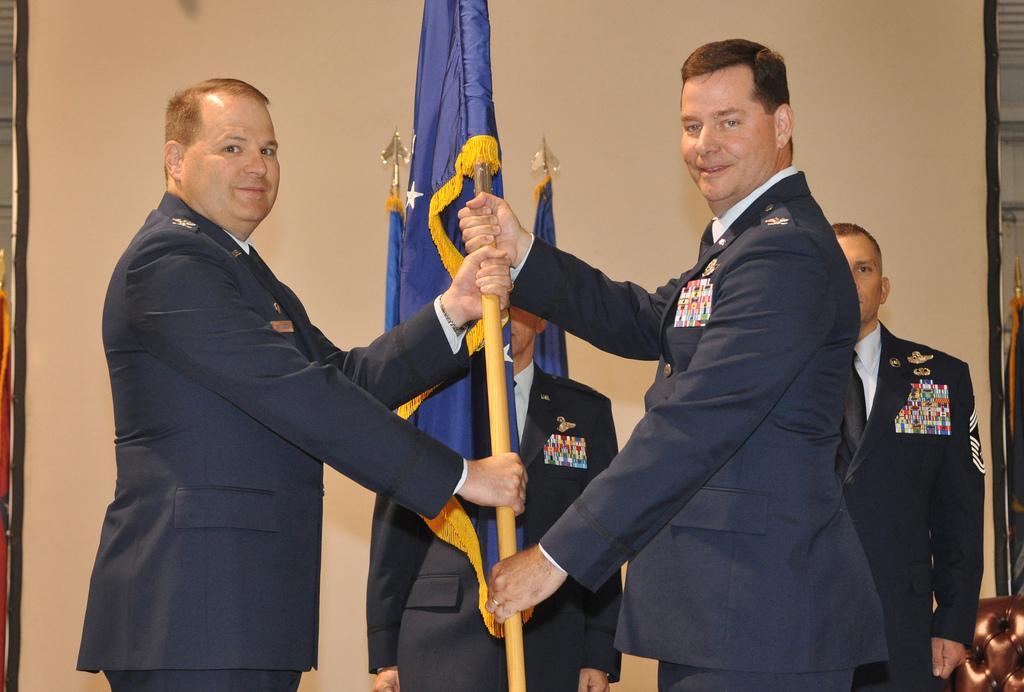Can you describe this image briefly? In this picture I can see group of men are standing and wearing uniforms. The men in the front are holding a flag in the hands. These men are smiling. In the background I can see a wall. 